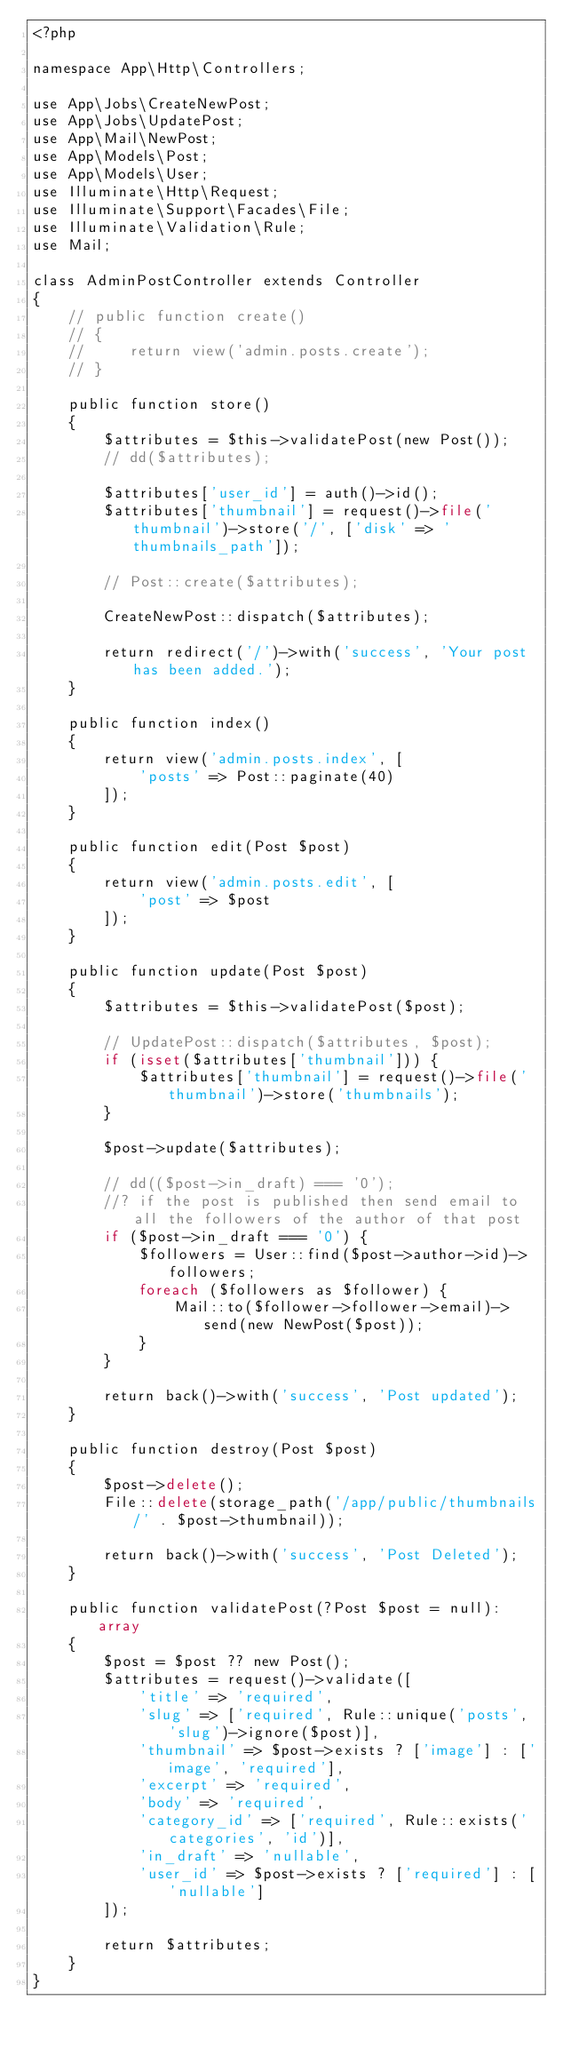<code> <loc_0><loc_0><loc_500><loc_500><_PHP_><?php

namespace App\Http\Controllers;

use App\Jobs\CreateNewPost;
use App\Jobs\UpdatePost;
use App\Mail\NewPost;
use App\Models\Post;
use App\Models\User;
use Illuminate\Http\Request;
use Illuminate\Support\Facades\File;
use Illuminate\Validation\Rule;
use Mail;

class AdminPostController extends Controller
{
    // public function create()
    // {
    //     return view('admin.posts.create');
    // }

    public function store()
    {
        $attributes = $this->validatePost(new Post());
        // dd($attributes);

        $attributes['user_id'] = auth()->id();
        $attributes['thumbnail'] = request()->file('thumbnail')->store('/', ['disk' => 'thumbnails_path']);

        // Post::create($attributes);

        CreateNewPost::dispatch($attributes);

        return redirect('/')->with('success', 'Your post has been added.');
    }

    public function index()
    {
        return view('admin.posts.index', [
            'posts' => Post::paginate(40)
        ]);
    }

    public function edit(Post $post)
    {
        return view('admin.posts.edit', [
            'post' => $post
        ]);
    }

    public function update(Post $post)
    {
        $attributes = $this->validatePost($post);

        // UpdatePost::dispatch($attributes, $post);
        if (isset($attributes['thumbnail'])) {
            $attributes['thumbnail'] = request()->file('thumbnail')->store('thumbnails');
        }

        $post->update($attributes);

        // dd(($post->in_draft) === '0');
        //? if the post is published then send email to all the followers of the author of that post
        if ($post->in_draft === '0') {
            $followers = User::find($post->author->id)->followers;
            foreach ($followers as $follower) {
                Mail::to($follower->follower->email)->send(new NewPost($post));
            }
        }

        return back()->with('success', 'Post updated');
    }

    public function destroy(Post $post)
    {
        $post->delete();
        File::delete(storage_path('/app/public/thumbnails/' . $post->thumbnail));

        return back()->with('success', 'Post Deleted');
    }

    public function validatePost(?Post $post = null): array
    {
        $post = $post ?? new Post();
        $attributes = request()->validate([
            'title' => 'required',
            'slug' => ['required', Rule::unique('posts', 'slug')->ignore($post)],
            'thumbnail' => $post->exists ? ['image'] : ['image', 'required'],
            'excerpt' => 'required',
            'body' => 'required',
            'category_id' => ['required', Rule::exists('categories', 'id')],
            'in_draft' => 'nullable',
            'user_id' => $post->exists ? ['required'] : ['nullable']
        ]);

        return $attributes;
    }
}
</code> 